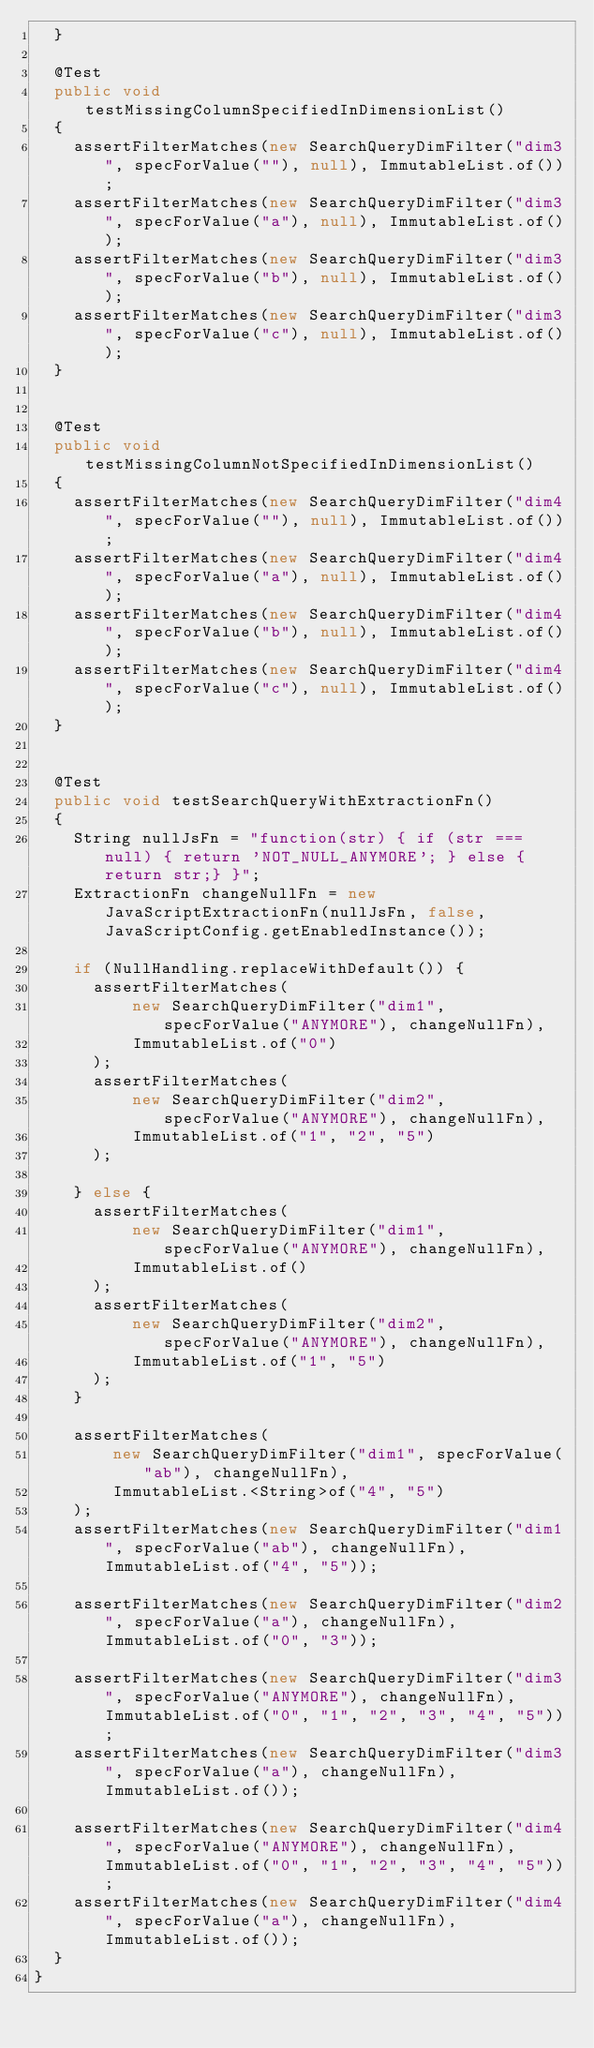Convert code to text. <code><loc_0><loc_0><loc_500><loc_500><_Java_>  }

  @Test
  public void testMissingColumnSpecifiedInDimensionList()
  {
    assertFilterMatches(new SearchQueryDimFilter("dim3", specForValue(""), null), ImmutableList.of());
    assertFilterMatches(new SearchQueryDimFilter("dim3", specForValue("a"), null), ImmutableList.of());
    assertFilterMatches(new SearchQueryDimFilter("dim3", specForValue("b"), null), ImmutableList.of());
    assertFilterMatches(new SearchQueryDimFilter("dim3", specForValue("c"), null), ImmutableList.of());
  }


  @Test
  public void testMissingColumnNotSpecifiedInDimensionList()
  {
    assertFilterMatches(new SearchQueryDimFilter("dim4", specForValue(""), null), ImmutableList.of());
    assertFilterMatches(new SearchQueryDimFilter("dim4", specForValue("a"), null), ImmutableList.of());
    assertFilterMatches(new SearchQueryDimFilter("dim4", specForValue("b"), null), ImmutableList.of());
    assertFilterMatches(new SearchQueryDimFilter("dim4", specForValue("c"), null), ImmutableList.of());
  }


  @Test
  public void testSearchQueryWithExtractionFn()
  {
    String nullJsFn = "function(str) { if (str === null) { return 'NOT_NULL_ANYMORE'; } else { return str;} }";
    ExtractionFn changeNullFn = new JavaScriptExtractionFn(nullJsFn, false, JavaScriptConfig.getEnabledInstance());

    if (NullHandling.replaceWithDefault()) {
      assertFilterMatches(
          new SearchQueryDimFilter("dim1", specForValue("ANYMORE"), changeNullFn),
          ImmutableList.of("0")
      );
      assertFilterMatches(
          new SearchQueryDimFilter("dim2", specForValue("ANYMORE"), changeNullFn),
          ImmutableList.of("1", "2", "5")
      );

    } else {
      assertFilterMatches(
          new SearchQueryDimFilter("dim1", specForValue("ANYMORE"), changeNullFn),
          ImmutableList.of()
      );
      assertFilterMatches(
          new SearchQueryDimFilter("dim2", specForValue("ANYMORE"), changeNullFn),
          ImmutableList.of("1", "5")
      );
    }

    assertFilterMatches(
        new SearchQueryDimFilter("dim1", specForValue("ab"), changeNullFn),
        ImmutableList.<String>of("4", "5")
    );
    assertFilterMatches(new SearchQueryDimFilter("dim1", specForValue("ab"), changeNullFn), ImmutableList.of("4", "5"));

    assertFilterMatches(new SearchQueryDimFilter("dim2", specForValue("a"), changeNullFn), ImmutableList.of("0", "3"));

    assertFilterMatches(new SearchQueryDimFilter("dim3", specForValue("ANYMORE"), changeNullFn), ImmutableList.of("0", "1", "2", "3", "4", "5"));
    assertFilterMatches(new SearchQueryDimFilter("dim3", specForValue("a"), changeNullFn), ImmutableList.of());

    assertFilterMatches(new SearchQueryDimFilter("dim4", specForValue("ANYMORE"), changeNullFn), ImmutableList.of("0", "1", "2", "3", "4", "5"));
    assertFilterMatches(new SearchQueryDimFilter("dim4", specForValue("a"), changeNullFn), ImmutableList.of());
  }
}
</code> 